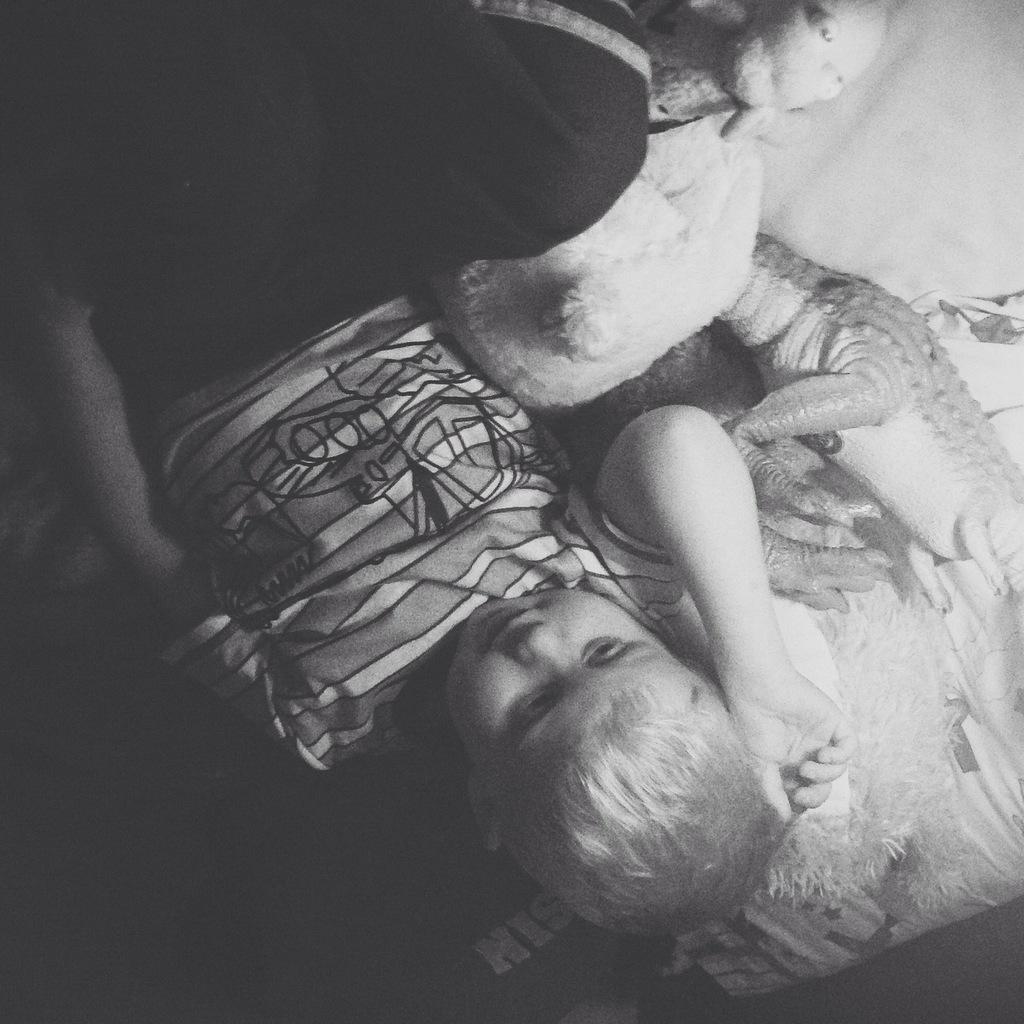Please provide a concise description of this image. In this image I can see a person sleeping and few toys on the bed. The image is in white and black. 